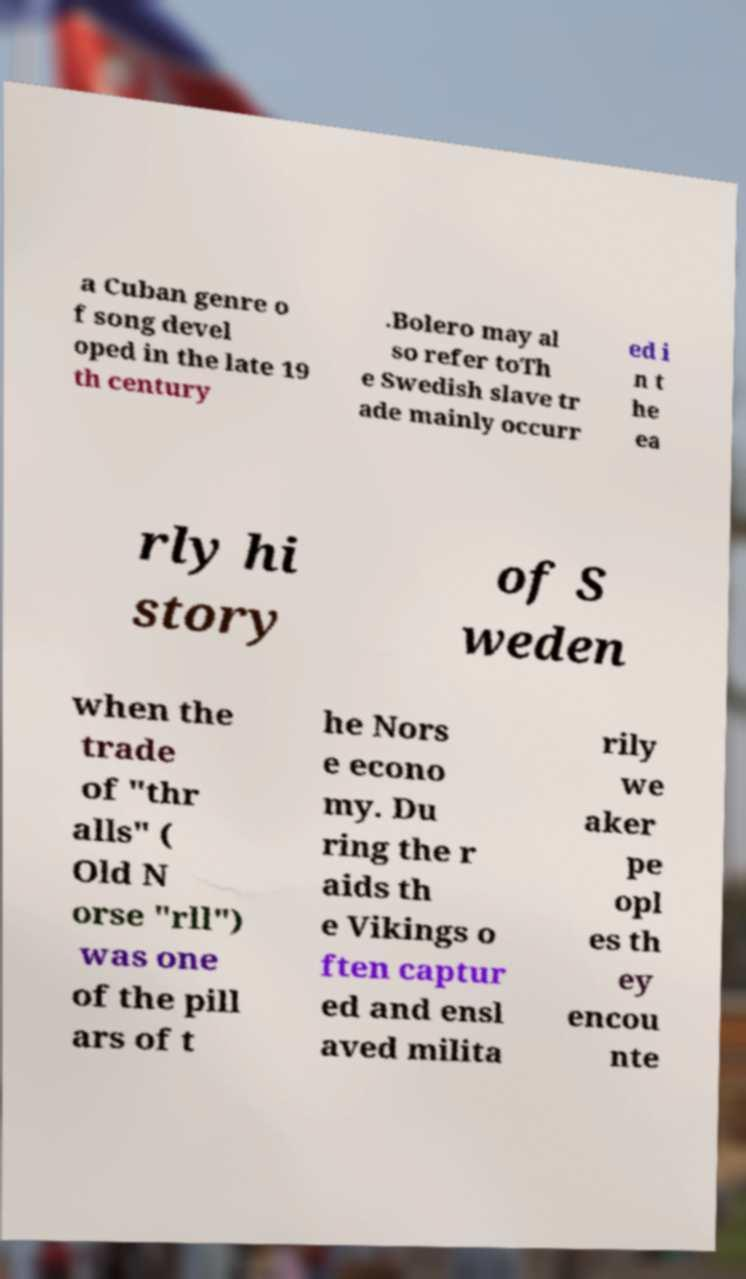Could you extract and type out the text from this image? a Cuban genre o f song devel oped in the late 19 th century .Bolero may al so refer toTh e Swedish slave tr ade mainly occurr ed i n t he ea rly hi story of S weden when the trade of "thr alls" ( Old N orse "rll") was one of the pill ars of t he Nors e econo my. Du ring the r aids th e Vikings o ften captur ed and ensl aved milita rily we aker pe opl es th ey encou nte 